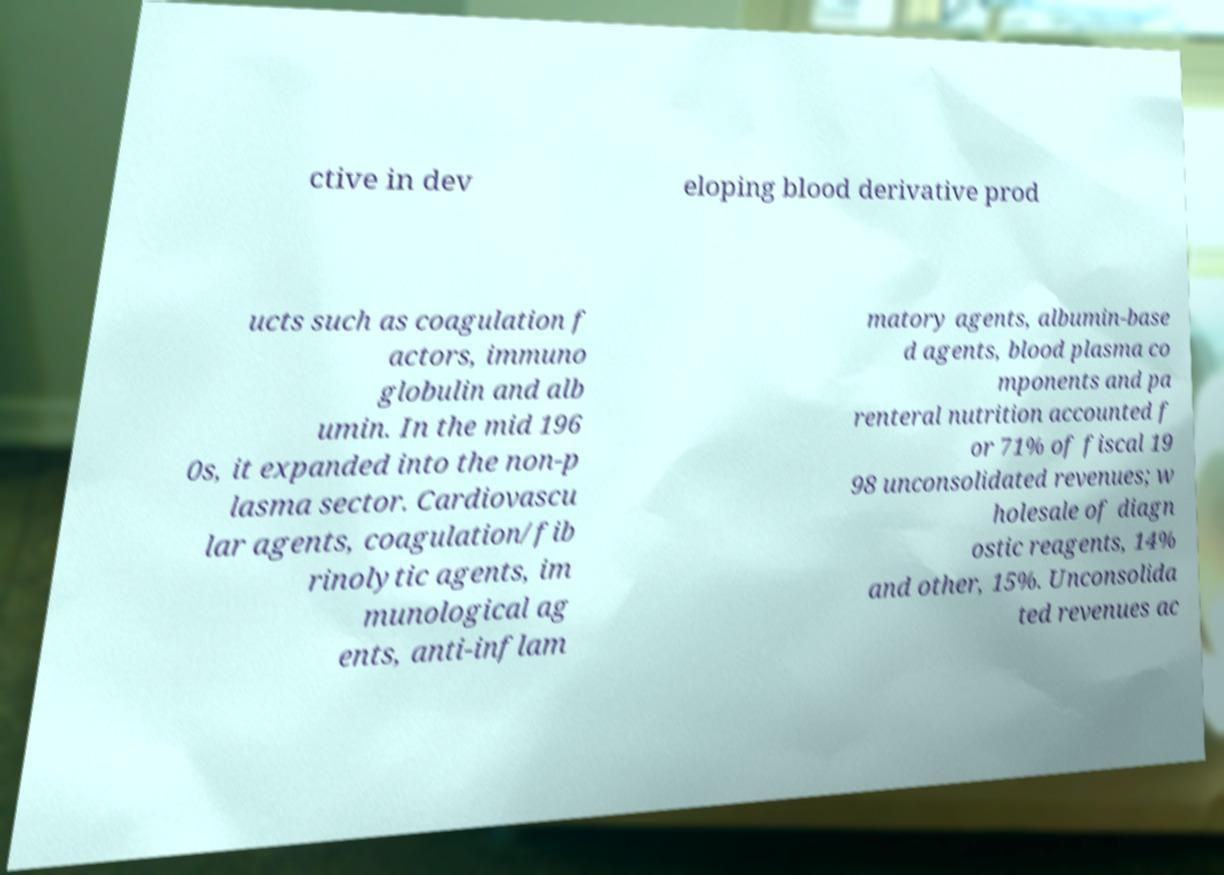Can you read and provide the text displayed in the image?This photo seems to have some interesting text. Can you extract and type it out for me? ctive in dev eloping blood derivative prod ucts such as coagulation f actors, immuno globulin and alb umin. In the mid 196 0s, it expanded into the non-p lasma sector. Cardiovascu lar agents, coagulation/fib rinolytic agents, im munological ag ents, anti-inflam matory agents, albumin-base d agents, blood plasma co mponents and pa renteral nutrition accounted f or 71% of fiscal 19 98 unconsolidated revenues; w holesale of diagn ostic reagents, 14% and other, 15%. Unconsolida ted revenues ac 